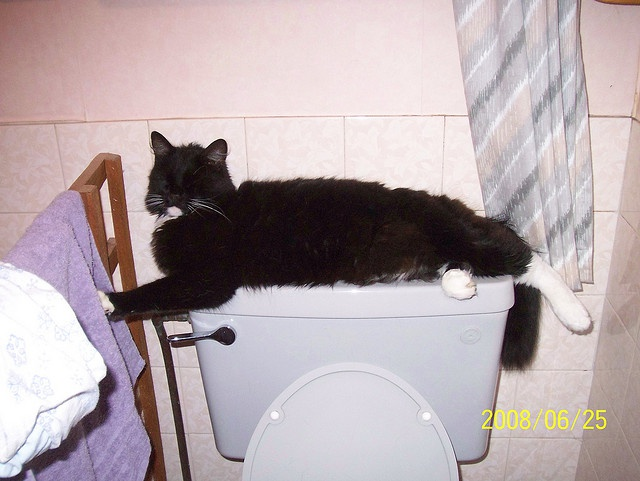Describe the objects in this image and their specific colors. I can see toilet in brown, lightgray, and darkgray tones and cat in brown, black, lightgray, and gray tones in this image. 